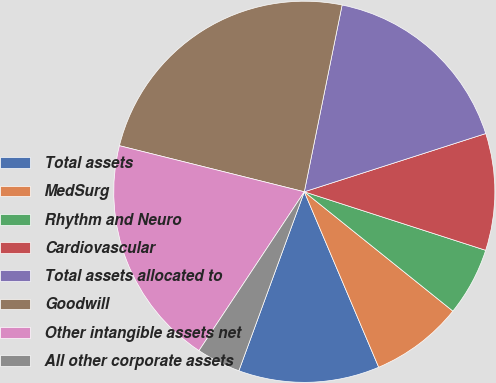<chart> <loc_0><loc_0><loc_500><loc_500><pie_chart><fcel>Total assets<fcel>MedSurg<fcel>Rhythm and Neuro<fcel>Cardiovascular<fcel>Total assets allocated to<fcel>Goodwill<fcel>Other intangible assets net<fcel>All other corporate assets<nl><fcel>11.96%<fcel>7.85%<fcel>5.8%<fcel>9.91%<fcel>16.88%<fcel>24.29%<fcel>19.57%<fcel>3.74%<nl></chart> 